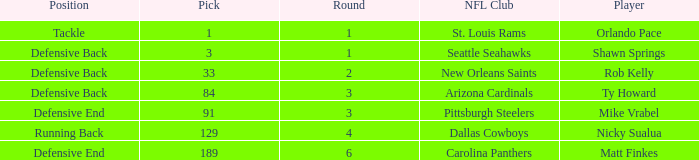What is the lowest pick that has arizona cardinals as the NFL club? 84.0. 